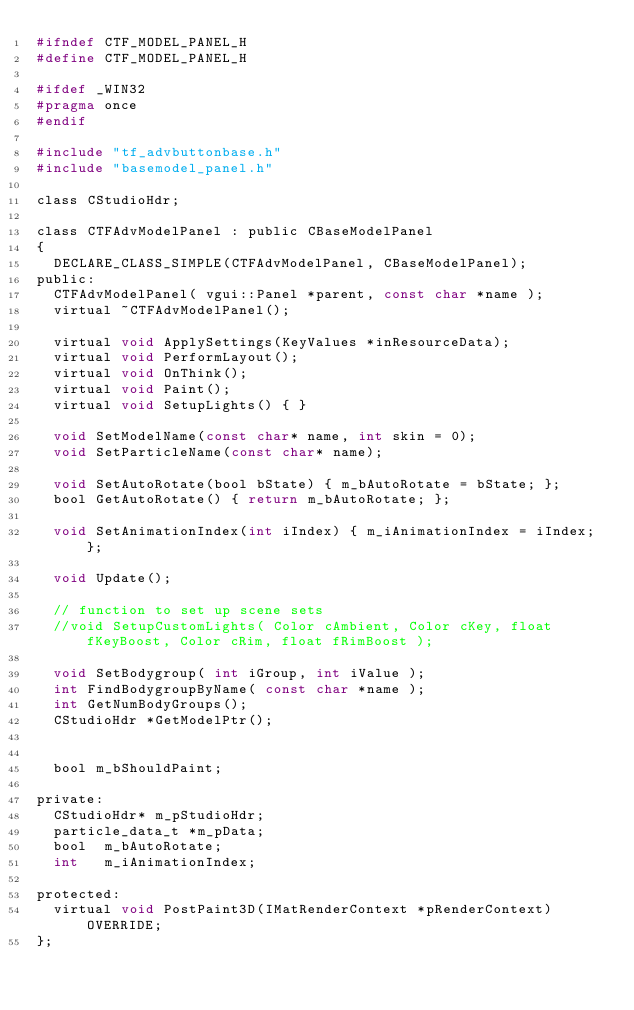Convert code to text. <code><loc_0><loc_0><loc_500><loc_500><_C_>#ifndef CTF_MODEL_PANEL_H
#define CTF_MODEL_PANEL_H

#ifdef _WIN32
#pragma once
#endif

#include "tf_advbuttonbase.h"
#include "basemodel_panel.h"

class CStudioHdr;

class CTFAdvModelPanel : public CBaseModelPanel
{
	DECLARE_CLASS_SIMPLE(CTFAdvModelPanel, CBaseModelPanel);
public:
	CTFAdvModelPanel( vgui::Panel *parent, const char *name );
	virtual ~CTFAdvModelPanel();

	virtual void ApplySettings(KeyValues *inResourceData);
	virtual void PerformLayout();
	virtual void OnThink();
	virtual void Paint();
	virtual void SetupLights() { }

	void SetModelName(const char* name, int skin = 0);
	void SetParticleName(const char* name);

	void SetAutoRotate(bool bState) { m_bAutoRotate = bState; };
	bool GetAutoRotate() { return m_bAutoRotate; };

	void SetAnimationIndex(int iIndex) { m_iAnimationIndex = iIndex; };

	void Update();

	// function to set up scene sets
	//void SetupCustomLights( Color cAmbient, Color cKey, float fKeyBoost, Color cRim, float fRimBoost );

	void SetBodygroup( int iGroup, int iValue );
	int FindBodygroupByName( const char *name );
	int GetNumBodyGroups();
	CStudioHdr *GetModelPtr();
	

	bool m_bShouldPaint;

private:
	CStudioHdr* m_pStudioHdr;
	particle_data_t *m_pData;
	bool	m_bAutoRotate;
	int		m_iAnimationIndex;

protected:
	virtual void PostPaint3D(IMatRenderContext *pRenderContext) OVERRIDE;
};

</code> 